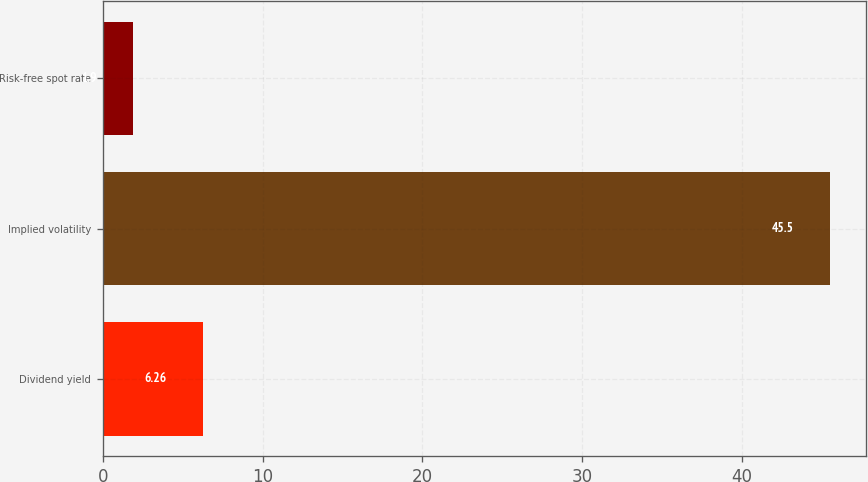Convert chart to OTSL. <chart><loc_0><loc_0><loc_500><loc_500><bar_chart><fcel>Dividend yield<fcel>Implied volatility<fcel>Risk-free spot rate<nl><fcel>6.26<fcel>45.5<fcel>1.9<nl></chart> 